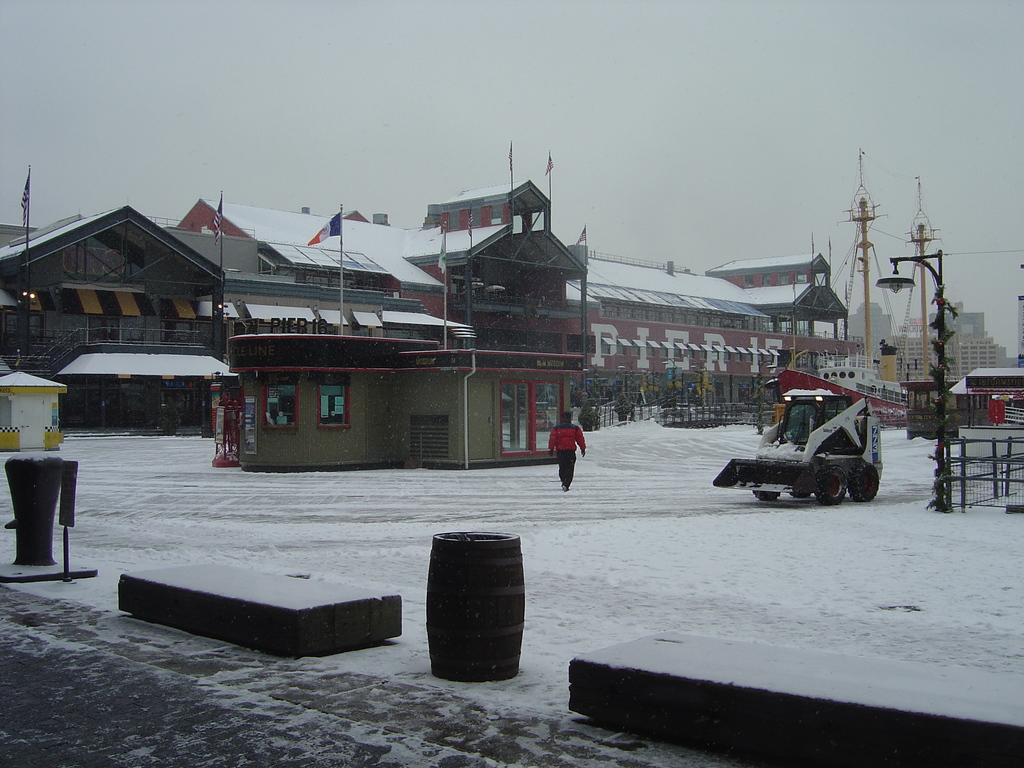What type of structures can be seen in the image? There are buildings in the image. What is attached to the flag posts? Flags are attached to the flag posts in the image. What construction equipment is visible in the image? Cranes are visible in the image. What type of lighting is present in the image? Street lights are in the image. What type of poles are present in the image? Street poles are present in the image. Is there a person in the image? Yes, there is a person in the image. What mode of transportation is visible in the image? A motor vehicle is visible in the image. What type of containers are in the image? Barrels are in the image. What is the condition of the roads in the image? Snow is on the roads in the image. What part of the natural environment is visible in the image? The sky is visible in the image. Where are the horses located in the image? There are no horses present in the image. What type of alley can be seen in the image? There is no alley present in the image. What type of medical facility is visible in the image? There is no hospital present in the image. 